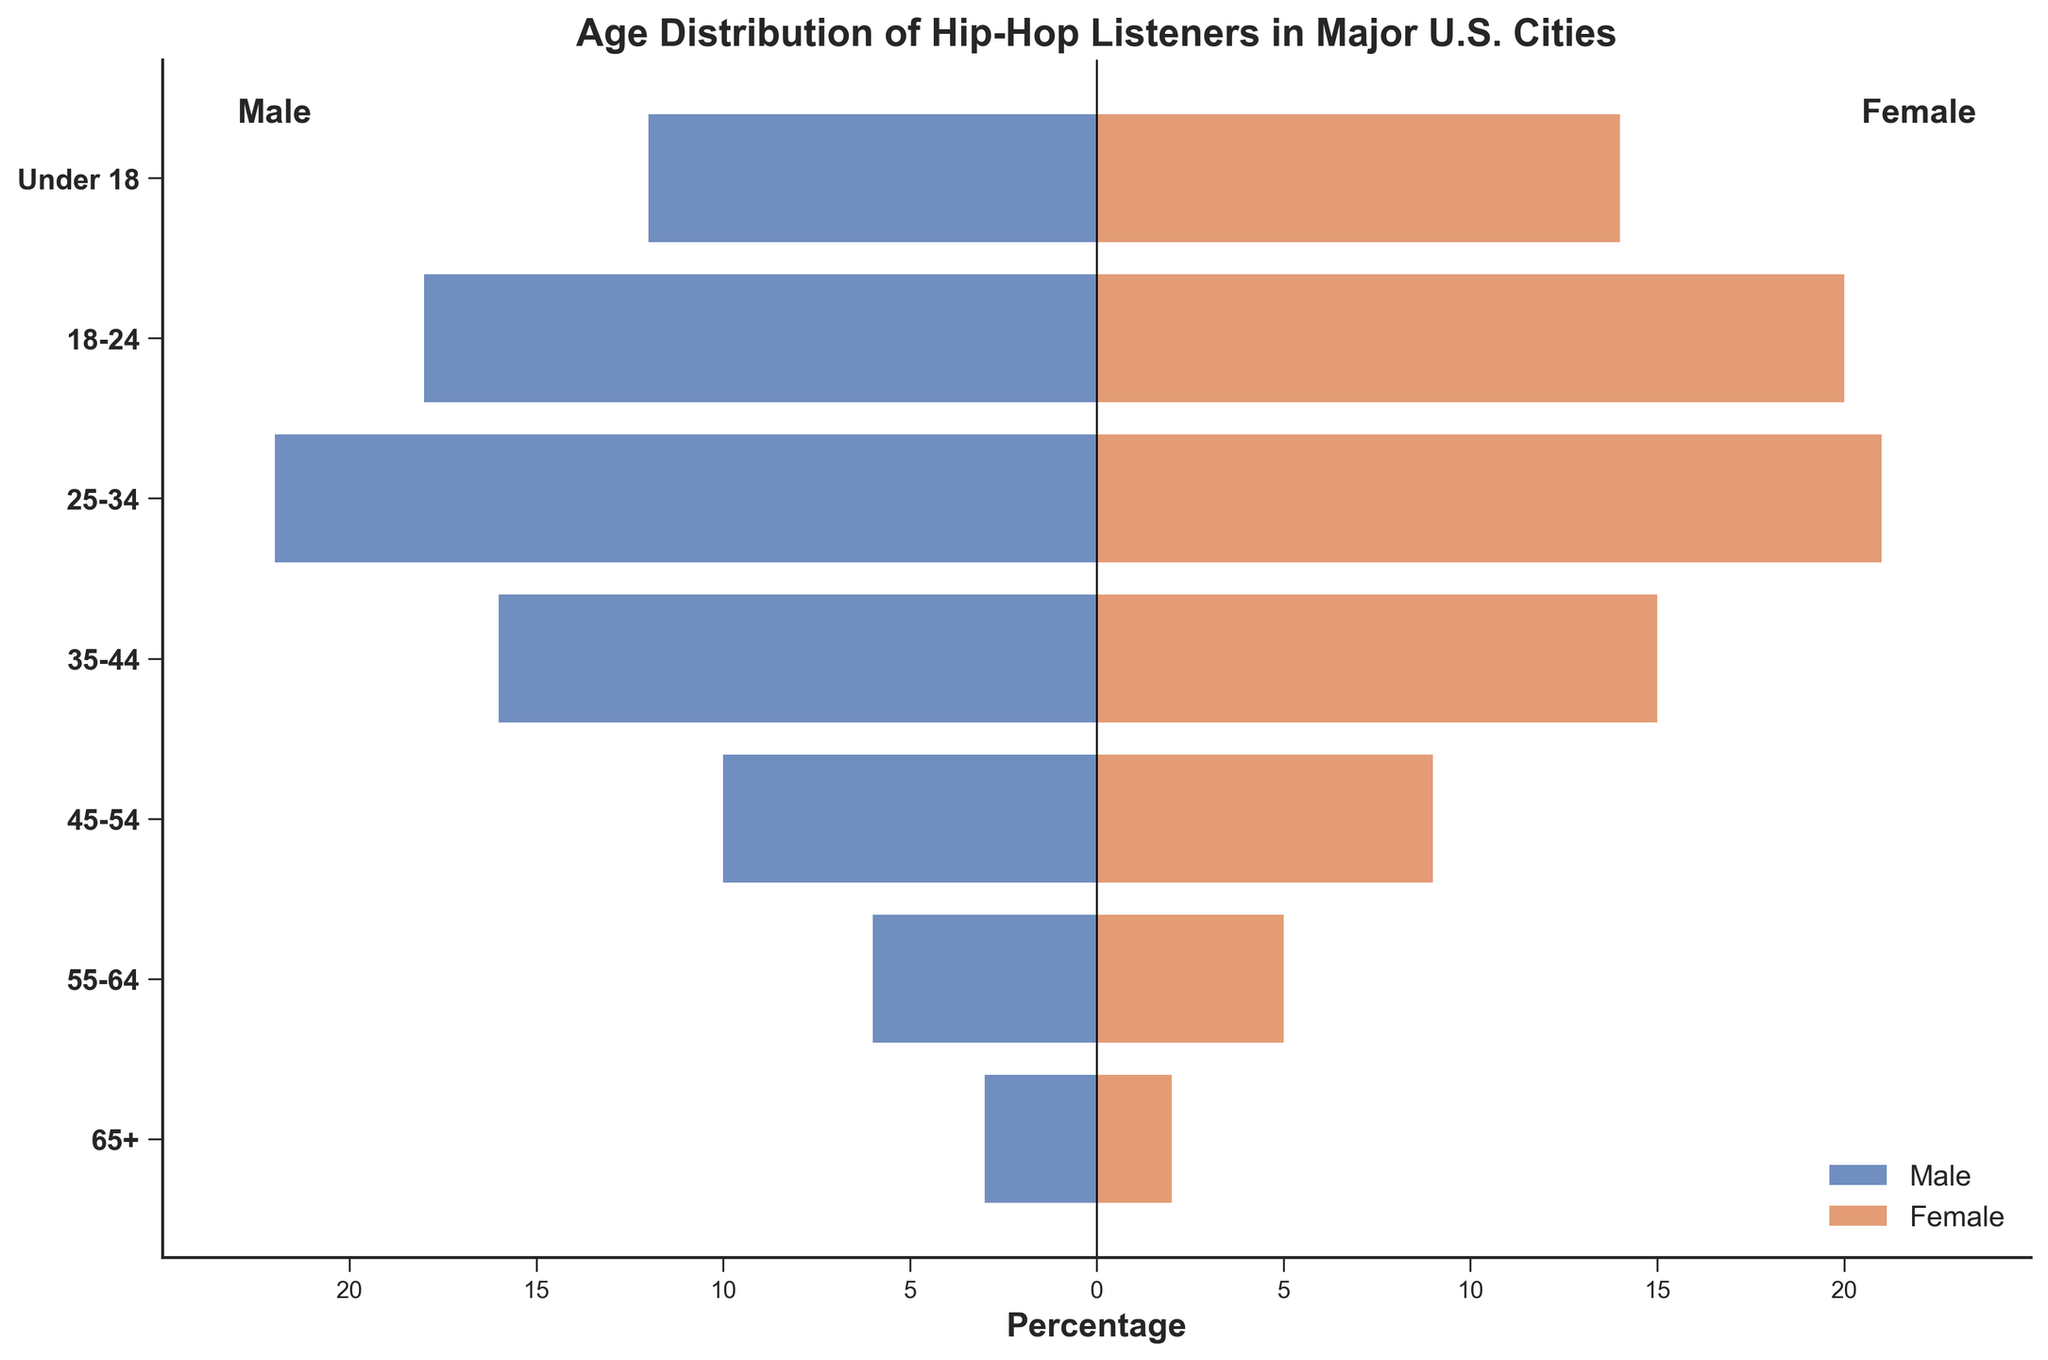what is the title of the figure? The title is located at the top of the figure and summarizes the content and purpose of the chart. It reads: "Age Distribution of Hip-Hop Listeners in Major U.S. Cities."
Answer: Age Distribution of Hip-Hop Listeners in Major U.S. Cities which age group has the highest percentage of male listeners? By looking at the horizontal bars on the left side, we can see which bar extends the furthest, indicating the highest percentage. The age group "25-34" has the longest bar.
Answer: 25-34 what is the percentage of female listeners in the 18-24 age group? Find the bar corresponding to "18-24" on the right side of the figure (female side), then look at its length and the label next to it.
Answer: 20% how many age groups have a higher percentage of female listeners than male listeners? Compare the length of the bars on the left (male) and right (female) sides for each age group. The age groups "Under 18", and "18-24" have higher female percentages. "25-34" is almost equal but not higher.
Answer: 2 which age group has the smallest difference in the percentage of male and female listeners? For each age group, compare the lengths of the male and female bars and determine the smallest absolute difference. The "25-34" group has almost equal percentages (22% males and 21% females).
Answer: 25-34 what is the combined percentage of male and female listeners in the 35-44 age group? Add the percentages of male and female listeners for the age group "35-44". It is 16% (males) + 15% (females).
Answer: 31% which gender has a higher number of listeners in the 45-54 age group? Compare the lengths of the bars on the left (male) and right (female) sides for the age group "45-54". The male bar extends further than the female bar.
Answer: Male in which age group is the combined percentage the lowest? Calculate the combined percentage for each age group: "Under 18" (26%), "18-24" (38%), "25-34" (43%), "35-44" (42%), "45-54" (19%), "55-64" (11%), "65+" (5%). The lowest combined percentage is for "65+" (5%)
Answer: 65+ what is the trend in the percentage of male listeners as the age group increases? Observe the lengths of the bars on the left (male) side from the youngest to the oldest age group. The male percentage tends to decrease as the age group increases, peaking at "25-34" and steadily decreasing afterward.
Answer: Decreasing how does the percentage of listeners in the 55-64 age group compare to the 65+ age group for both genders? Compare the lengths of the male and female bars for the age groups "55-64" and "65+" separately. Both the percentages of male and female listeners in the "55-64" group (6% and 5%) are higher than those in the "65+" group (3% and 2%).
Answer: Higher in 55-64 